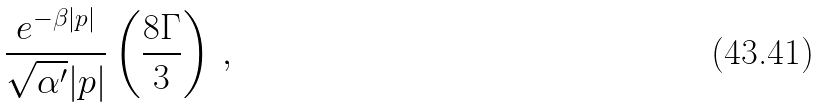Convert formula to latex. <formula><loc_0><loc_0><loc_500><loc_500>\frac { e ^ { - \beta | p | } } { \sqrt { \alpha ^ { \prime } } | p | } \left ( \frac { 8 \Gamma } { 3 } \right ) \, ,</formula> 